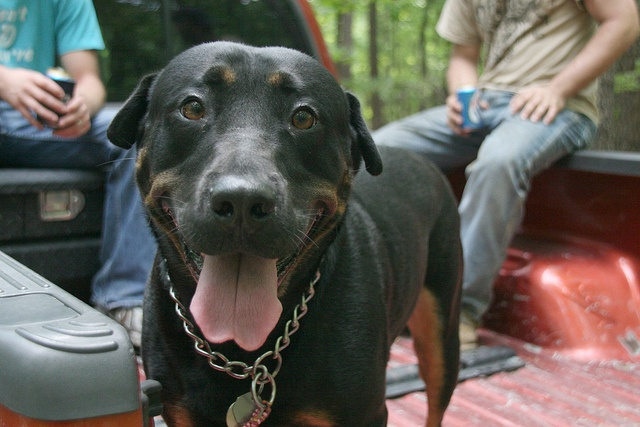Describe the objects in this image and their specific colors. I can see dog in lightblue, black, gray, darkgray, and maroon tones, truck in lightblue, black, lightpink, maroon, and salmon tones, people in lightblue, gray, darkgray, and lightgray tones, people in teal, black, and gray tones, and cup in lightblue, darkgray, gray, and lightgray tones in this image. 